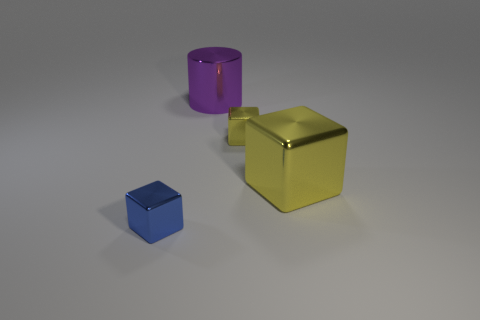How many other objects are there of the same material as the blue cube?
Ensure brevity in your answer.  3. What size is the cube that is on the left side of the large purple object?
Your response must be concise. Small. What number of cubes are to the left of the shiny cylinder and to the right of the metal cylinder?
Ensure brevity in your answer.  0. The cube that is left of the tiny metal cube right of the blue metallic object is made of what material?
Your response must be concise. Metal. Are any red blocks visible?
Your answer should be very brief. No. There is a purple object that is the same material as the tiny blue cube; what is its shape?
Ensure brevity in your answer.  Cylinder. What material is the tiny object that is behind the blue block?
Give a very brief answer. Metal. There is a tiny metal block behind the big metal block; is it the same color as the large shiny cube?
Provide a succinct answer. Yes. There is a yellow metal thing that is in front of the tiny metallic cube that is behind the blue thing; what size is it?
Keep it short and to the point. Large. Are there more big metallic objects to the right of the blue thing than blue blocks?
Keep it short and to the point. Yes. 